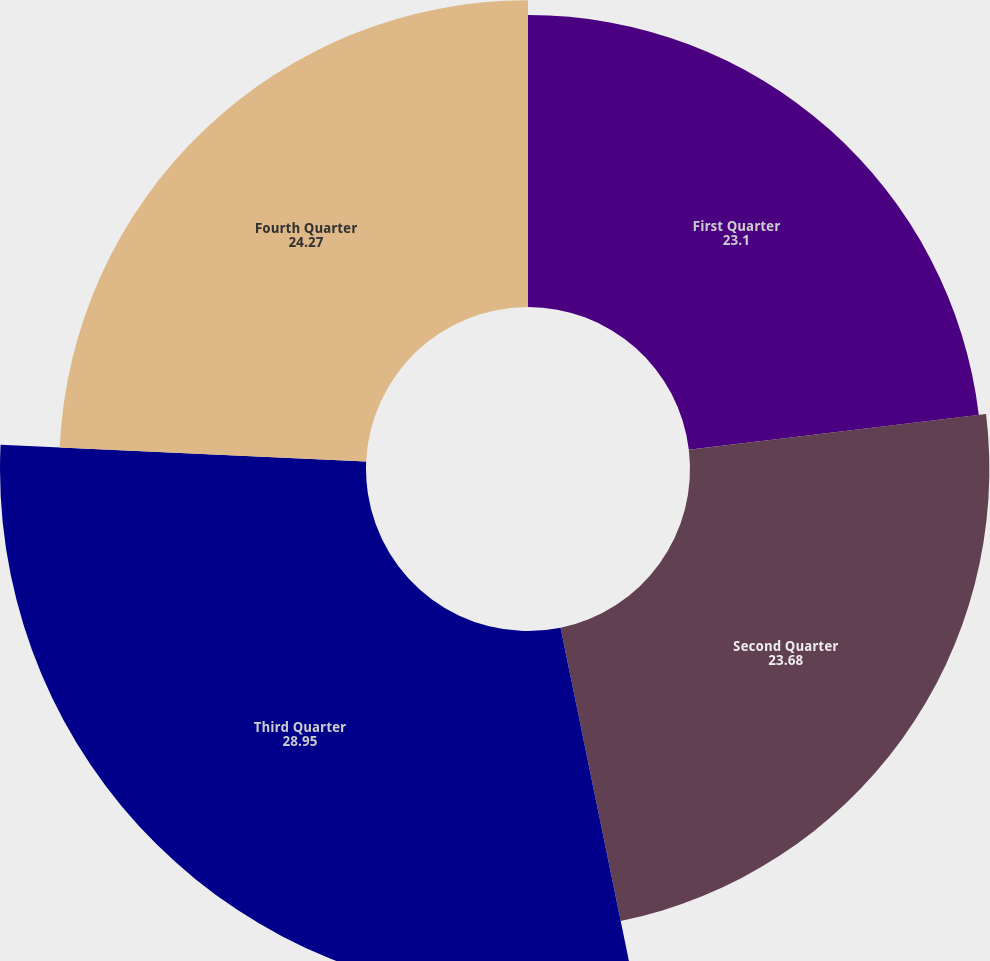<chart> <loc_0><loc_0><loc_500><loc_500><pie_chart><fcel>First Quarter<fcel>Second Quarter<fcel>Third Quarter<fcel>Fourth Quarter<nl><fcel>23.1%<fcel>23.68%<fcel>28.95%<fcel>24.27%<nl></chart> 